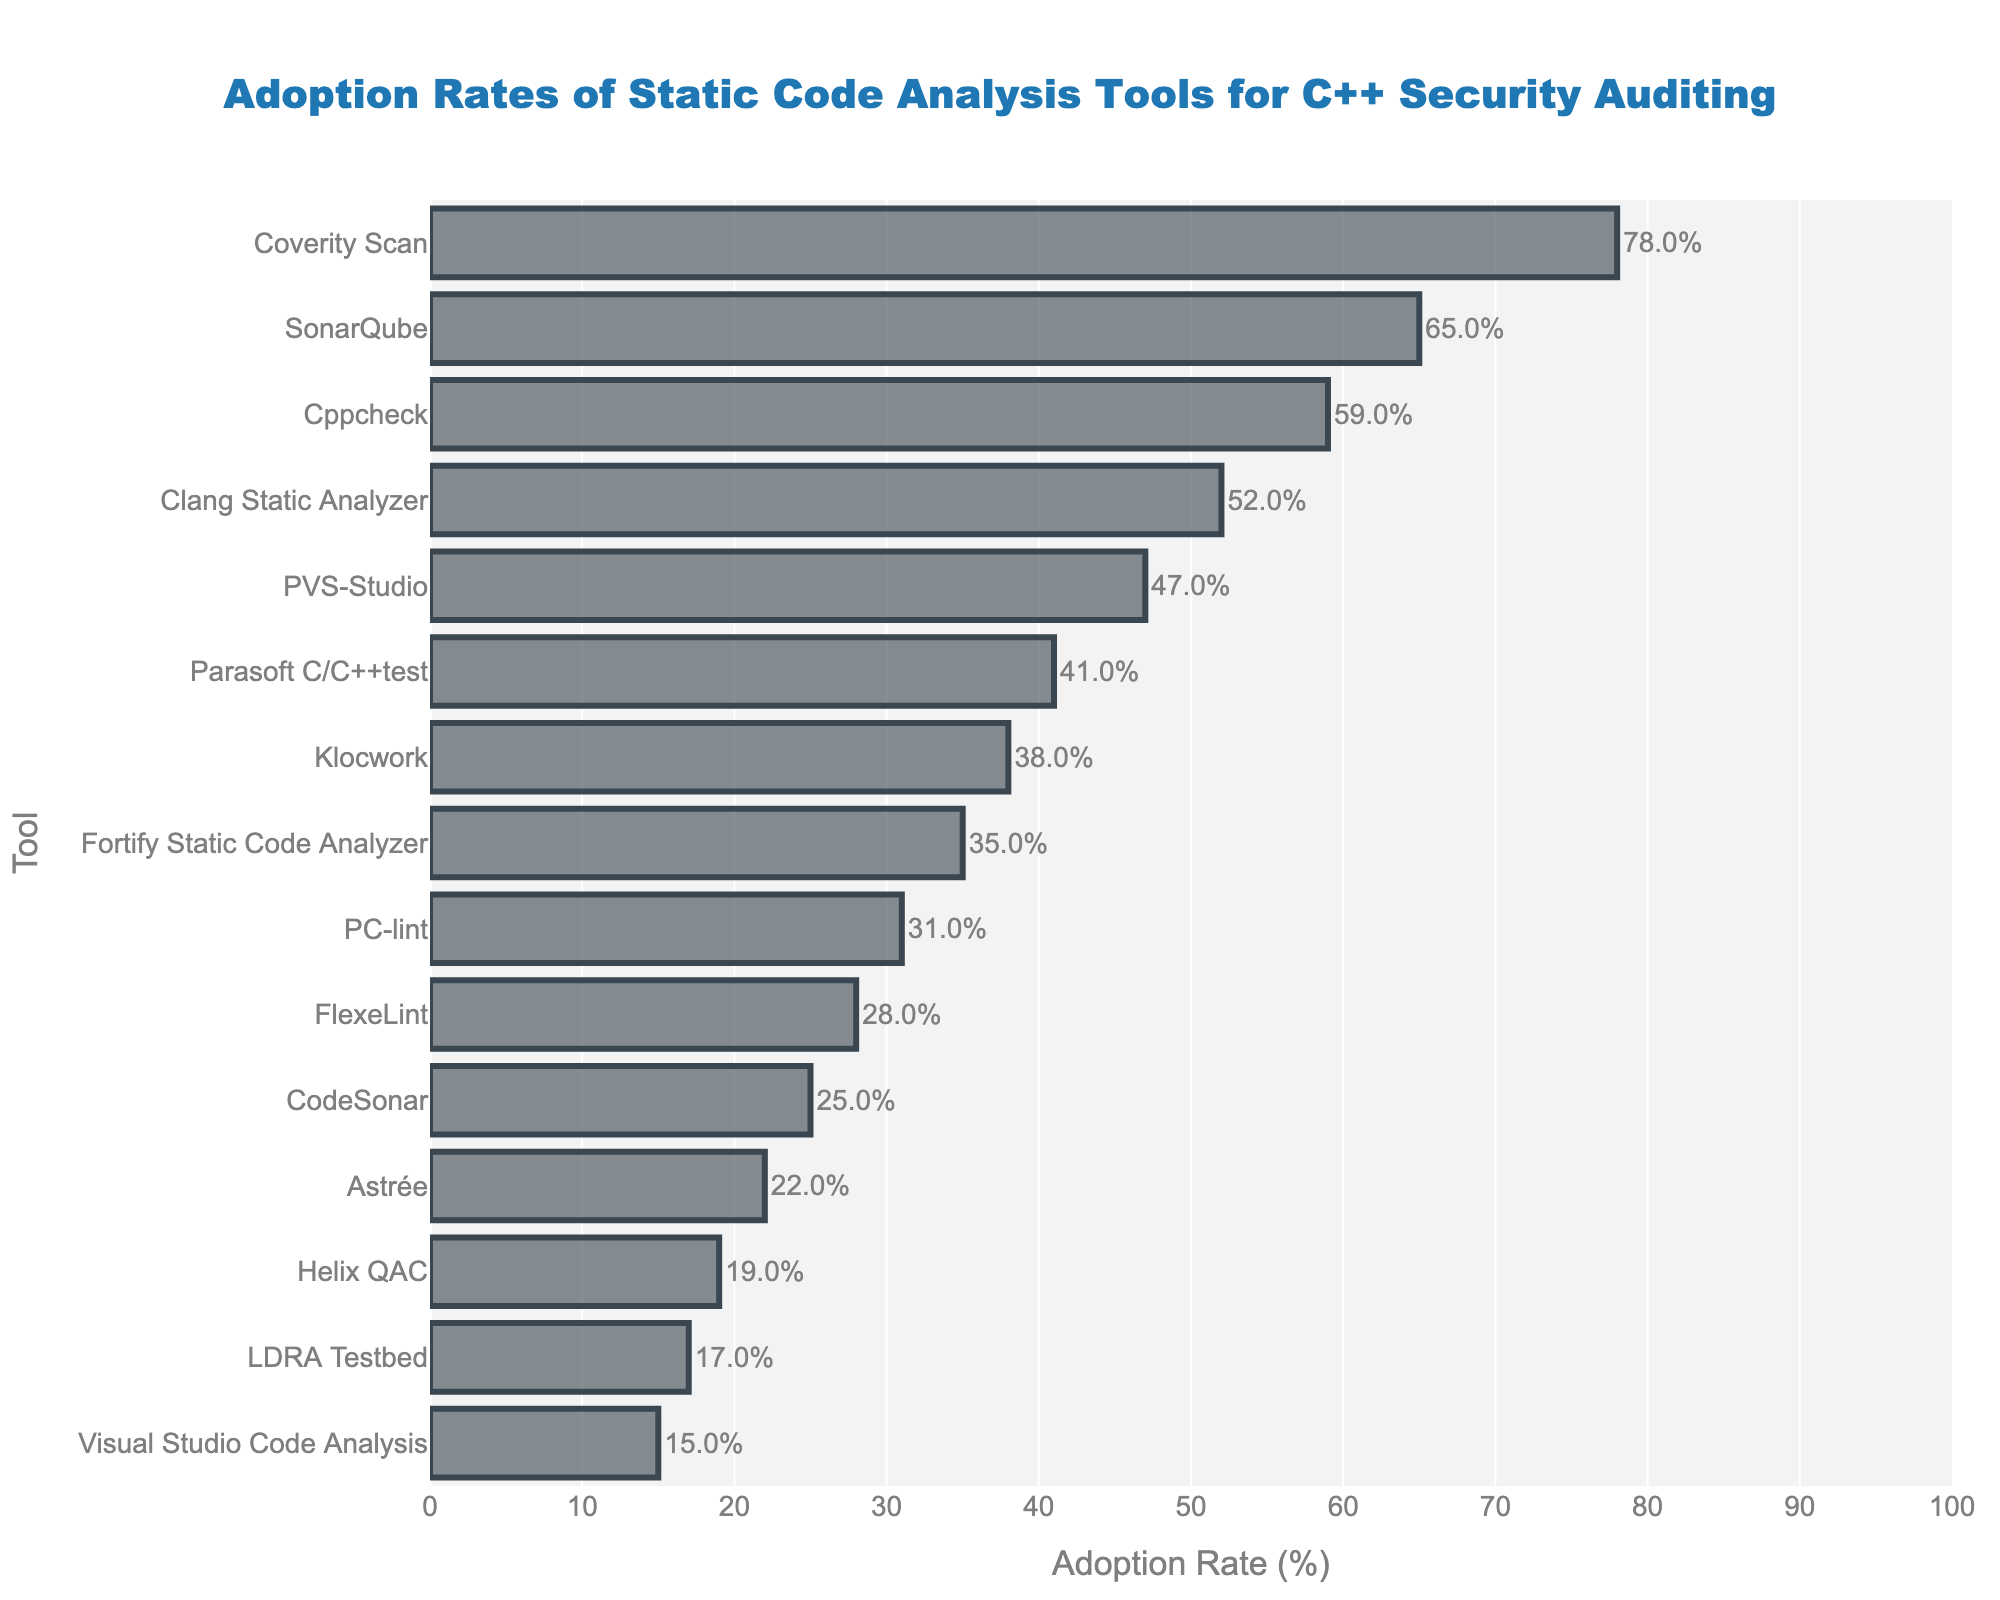Which tool has the highest adoption rate? By observing the bar representing the highest length in the figure, we see that "Coverity Scan" is at the top.
Answer: Coverity Scan How many tools have an adoption rate of more than 50%? Count the tools with bars extending beyond the 50% mark on the x-axis: Coverity Scan, SonarQube, Cppcheck, Clang Static Analyzer.
Answer: 4 What is the difference in adoption rates between PVS-Studio and Fortify Static Code Analyzer? PVS-Studio has an adoption rate of 47% and Fortify Static Code Analyzer has 35%. The difference is 47 - 35 = 12.
Answer: 12% Which tool has a lower adoption rate, Klocwork or FlexeLint? By comparing the lengths of the bars for Klocwork (38%) and FlexeLint (28%), FlexeLint is shorter.
Answer: FlexeLint What is the average adoption rate of the top 3 tools? The top 3 tools are Coverity Scan (78%), SonarQube (65%), and Cppcheck (59%). Their average is (78 + 65 + 59) / 3 = 67.33.
Answer: 67.33% Which tool has more adoption, Astrée or PC-lint? Astrée has 22%, and PC-lint has 31%. By comparing bar lengths, PC-lint is longer.
Answer: PC-lint By how much does the adoption rate of Clang Static Analyzer exceed that of Helix QAC? Clang Static Analyzer has an adoption rate of 52%, and Helix QAC has 19%. The difference is 52 - 19 = 33.
Answer: 33% Among the tools with adoption rates below 50%, which one has the highest rate? Among the tools below 50%, PVS-Studio has the highest rate at 47%.
Answer: PVS-Studio 